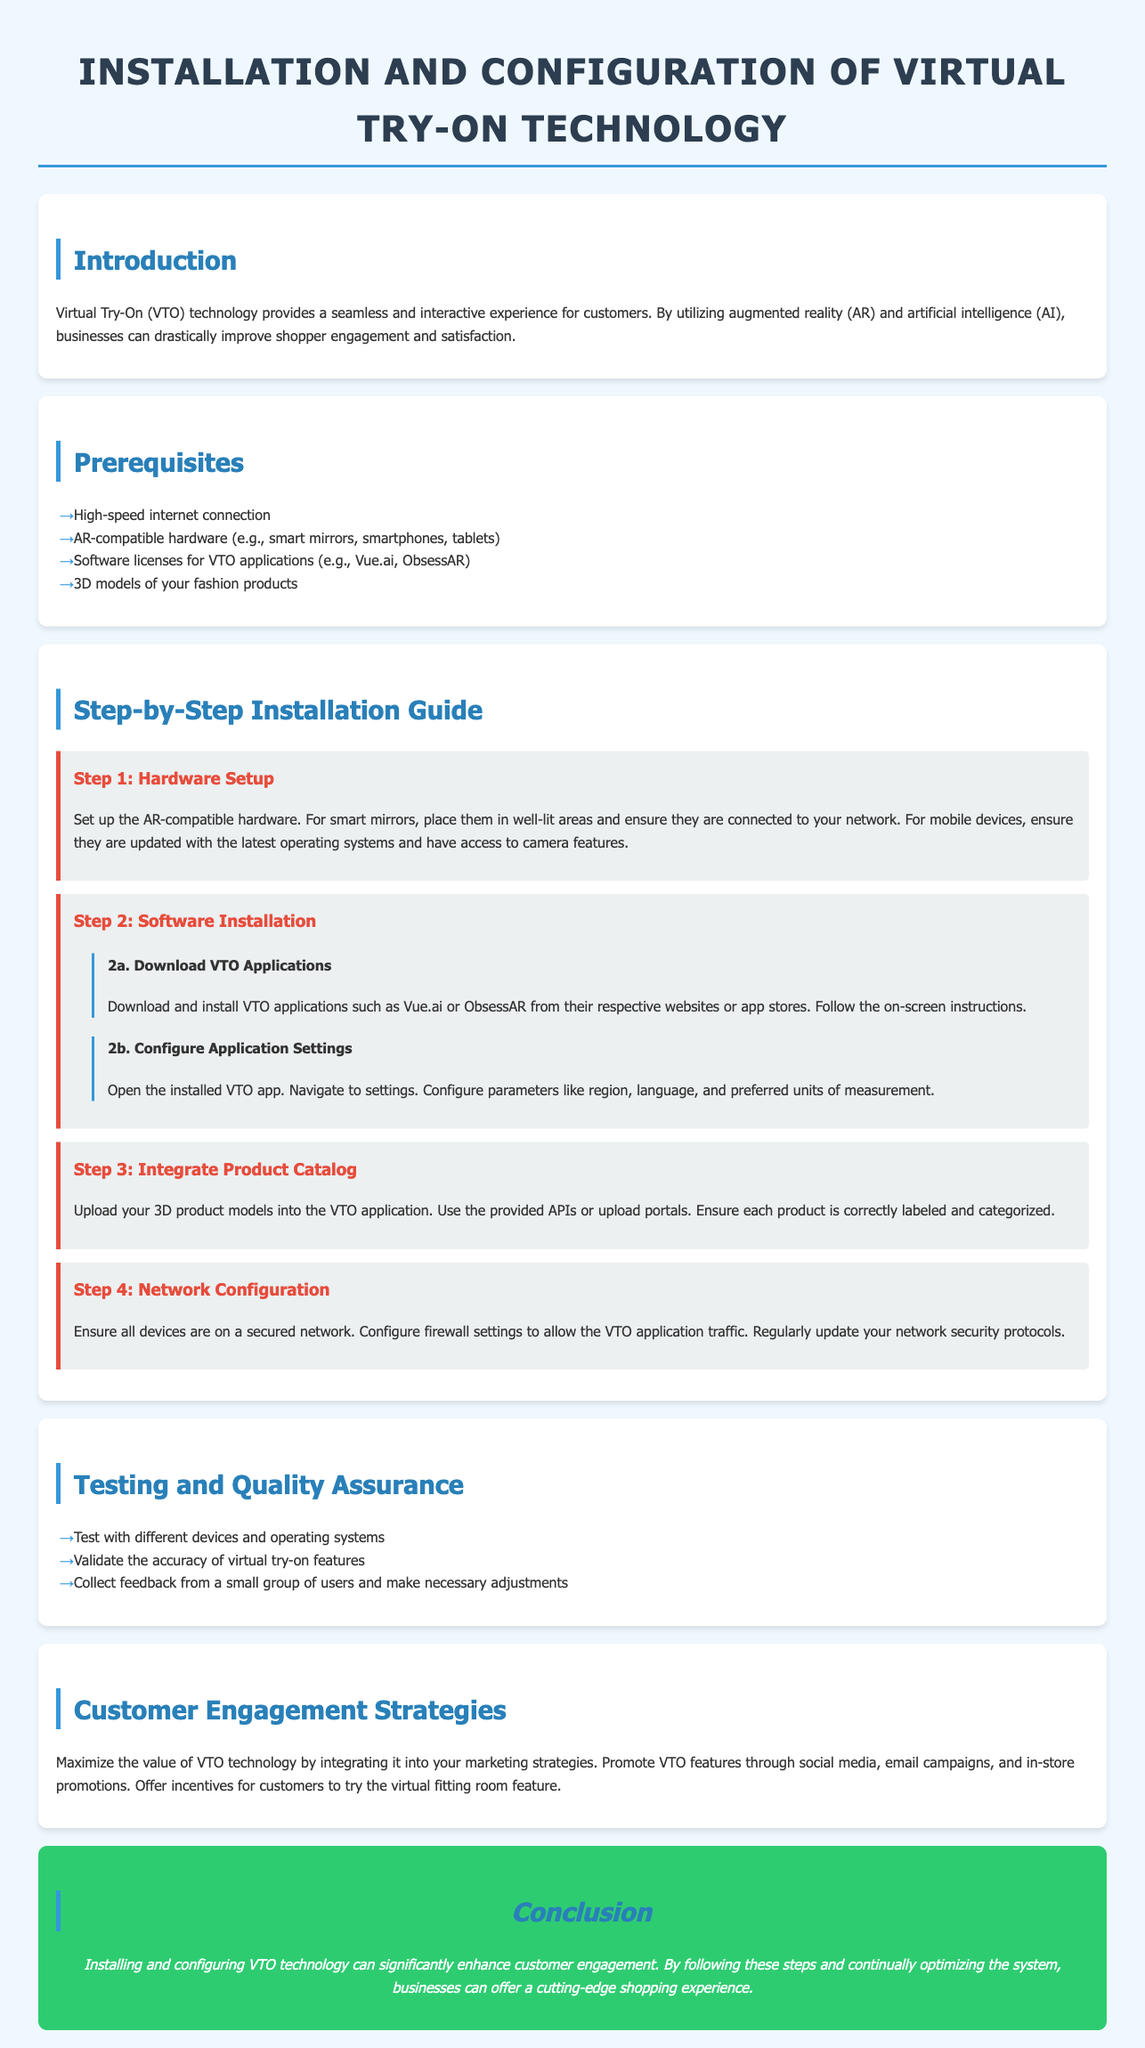What is the title of the document? The title is the main heading of the document, which is stated in the HTML title tag.
Answer: Installation and Configuration of Virtual Try-On Technology What technology does the document cover? The document highlights a specific technology aimed at customer engagement, mentioned in the introduction section.
Answer: Virtual Try-On (VTO) How many steps are provided in the installation guide? The number of steps can be counted from the distinct sections listed under the Step-by-Step Installation Guide heading.
Answer: 4 What is a prerequisite for using VTO technology? Prerequisites are listed in a bulleted format, detailing necessary requirements.
Answer: High-speed internet connection What does step 3 involve? Step 3 describes the specific task to be completed in that part of the installation process.
Answer: Integrate Product Catalog What should be tested according to the document? The document advises on testing practices relevant to virtual try-on technology functionality.
Answer: Different devices and operating systems What strategy is suggested to maximize VTO technology's value? This strategy is mentioned in the Customer Engagement Strategies section.
Answer: Promote VTO features What should be configured for network security? The document outlines necessary configurations related to network security, as indicated in step 4.
Answer: Firewall settings 